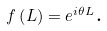Convert formula to latex. <formula><loc_0><loc_0><loc_500><loc_500>f \left ( L \right ) = e ^ { i \theta L } \text {.}</formula> 